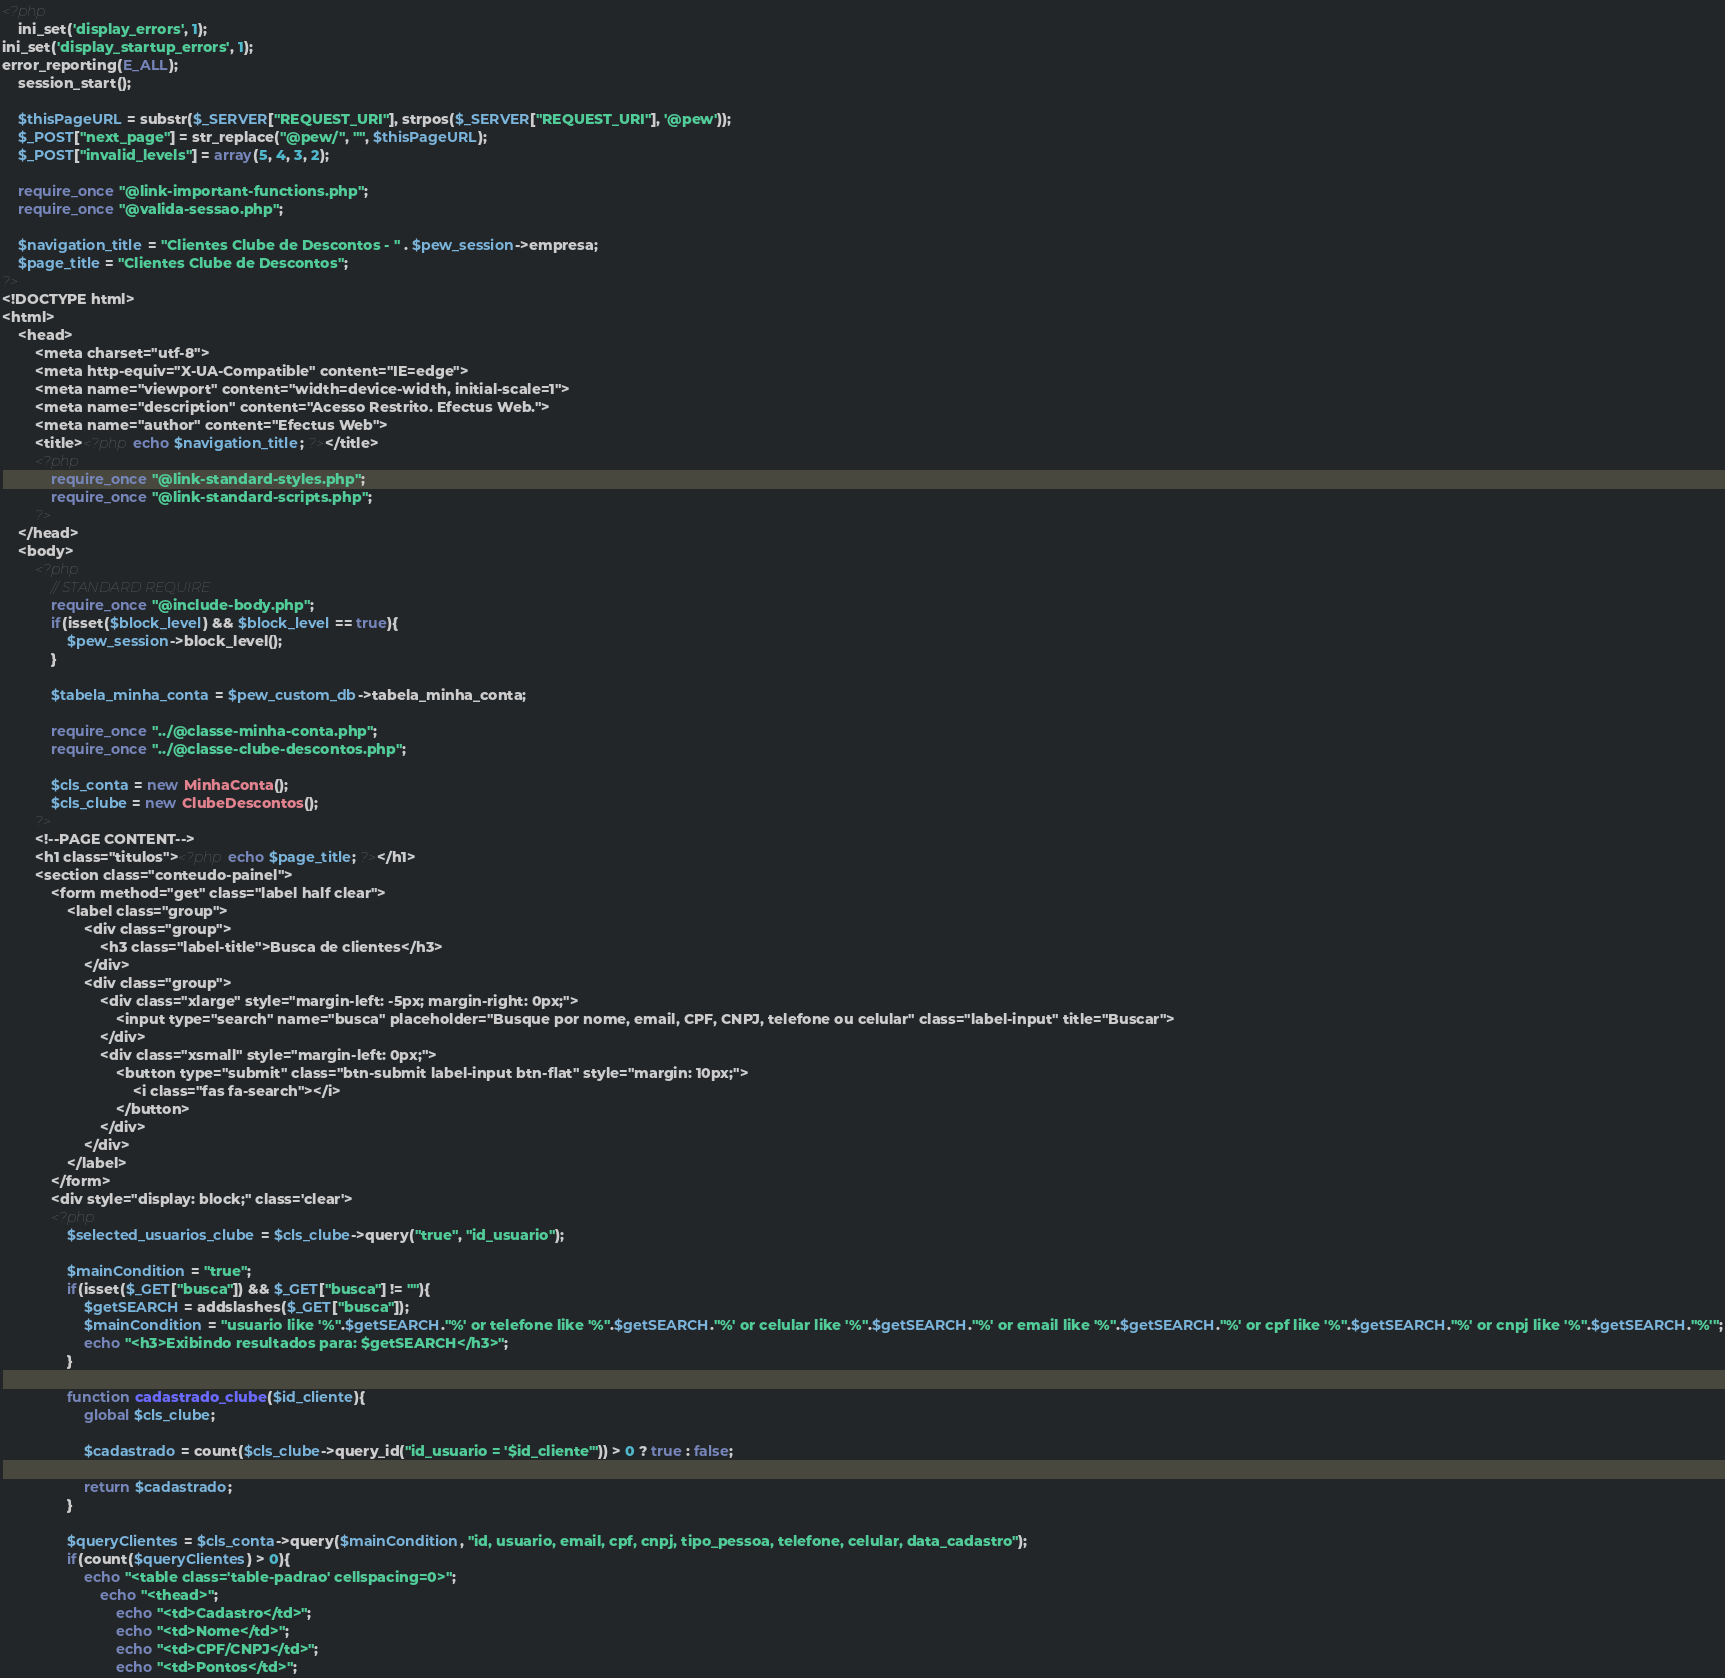<code> <loc_0><loc_0><loc_500><loc_500><_PHP_><?php
	ini_set('display_errors', 1);
ini_set('display_startup_errors', 1);
error_reporting(E_ALL);
    session_start();
    
    $thisPageURL = substr($_SERVER["REQUEST_URI"], strpos($_SERVER["REQUEST_URI"], '@pew'));
    $_POST["next_page"] = str_replace("@pew/", "", $thisPageURL);
    $_POST["invalid_levels"] = array(5, 4, 3, 2);
    
    require_once "@link-important-functions.php";
    require_once "@valida-sessao.php";

    $navigation_title = "Clientes Clube de Descontos - " . $pew_session->empresa;
    $page_title = "Clientes Clube de Descontos";
?>
<!DOCTYPE html>
<html>
    <head>
        <meta charset="utf-8">
        <meta http-equiv="X-UA-Compatible" content="IE=edge">
        <meta name="viewport" content="width=device-width, initial-scale=1">
        <meta name="description" content="Acesso Restrito. Efectus Web.">
        <meta name="author" content="Efectus Web">
        <title><?php echo $navigation_title; ?></title>
        <?php
            require_once "@link-standard-styles.php";
            require_once "@link-standard-scripts.php";
        ?>
    </head>
    <body>
        <?php
            // STANDARD REQUIRE
            require_once "@include-body.php";
            if(isset($block_level) && $block_level == true){
                $pew_session->block_level();
            }

            $tabela_minha_conta = $pew_custom_db->tabela_minha_conta;
		
			require_once "../@classe-minha-conta.php";
            require_once "../@classe-clube-descontos.php";

			$cls_conta = new MinhaConta();
            $cls_clube = new ClubeDescontos();
        ?>
        <!--PAGE CONTENT-->
        <h1 class="titulos"><?php echo $page_title; ?></h1>
        <section class="conteudo-painel">
            <form method="get" class="label half clear">
                <label class="group">
                    <div class="group">
                        <h3 class="label-title">Busca de clientes</h3>
                    </div>
                    <div class="group">
                        <div class="xlarge" style="margin-left: -5px; margin-right: 0px;">
                            <input type="search" name="busca" placeholder="Busque por nome, email, CPF, CNPJ, telefone ou celular" class="label-input" title="Buscar">
                        </div>
                        <div class="xsmall" style="margin-left: 0px;">
                            <button type="submit" class="btn-submit label-input btn-flat" style="margin: 10px;">
                                <i class="fas fa-search"></i>
                            </button>
                        </div>
                    </div>
                </label>
            </form>
			<div style="display: block;" class='clear'>
            <?php
                $selected_usuarios_clube = $cls_clube->query("true", "id_usuario");

				$mainCondition = "true";
                if(isset($_GET["busca"]) && $_GET["busca"] != ""){
                    $getSEARCH = addslashes($_GET["busca"]);
                    $mainCondition = "usuario like '%".$getSEARCH."%' or telefone like '%".$getSEARCH."%' or celular like '%".$getSEARCH."%' or email like '%".$getSEARCH."%' or cpf like '%".$getSEARCH."%' or cnpj like '%".$getSEARCH."%'";
                    echo "<h3>Exibindo resultados para: $getSEARCH</h3>";
                }

                function cadastrado_clube($id_cliente){
                    global $cls_clube;

                    $cadastrado = count($cls_clube->query_id("id_usuario = '$id_cliente'")) > 0 ? true : false;

                    return $cadastrado;
                }
			
				$queryClientes = $cls_conta->query($mainCondition, "id, usuario, email, cpf, cnpj, tipo_pessoa, telefone, celular, data_cadastro");
                if(count($queryClientes) > 0){
					echo "<table class='table-padrao' cellspacing=0>";
						echo "<thead>";
							echo "<td>Cadastro</td>";
							echo "<td>Nome</td>";
							echo "<td>CPF/CNPJ</td>";
							echo "<td>Pontos</td>";</code> 